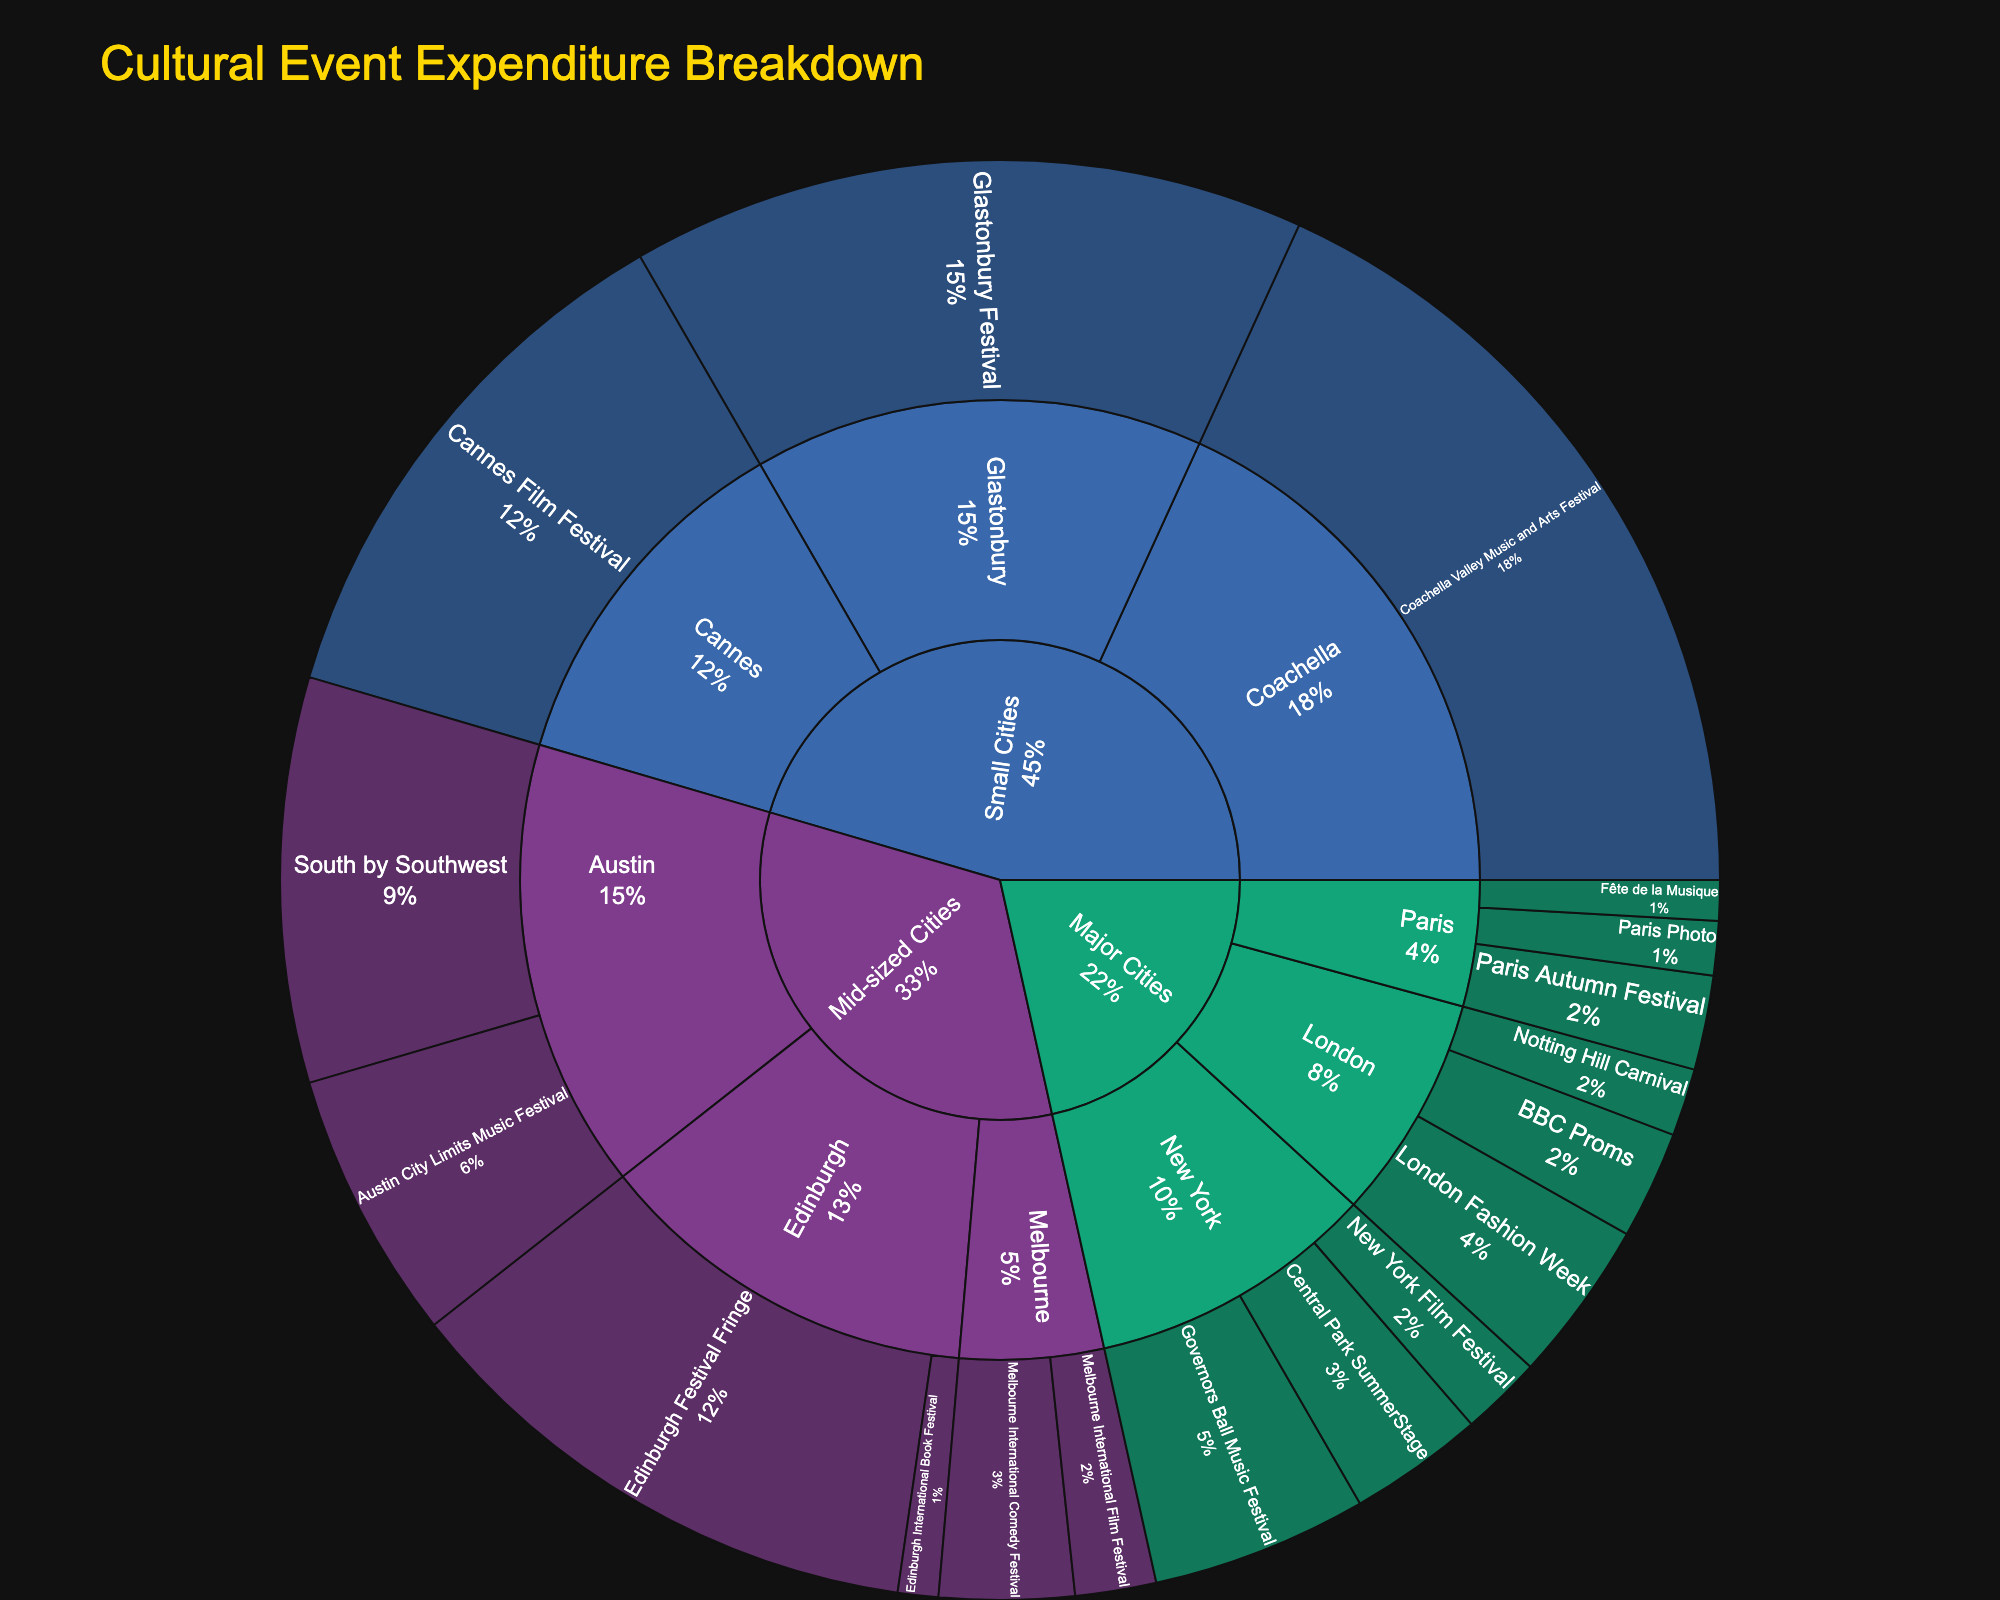what is the title of the plot? The title is usually at the top of the plot. For this sunburst chart, it's labeled as 'Cultural Event Expenditure Breakdown'.
Answer: Cultural Event Expenditure Breakdown Which event in Small Cities has the highest expenditure? In the plot, the largest segment under Small Cities with the most expenditure is the 'Coachella Valley Music and Arts Festival', indicated by the largest size and expenditure label.
Answer: Coachella Valley Music and Arts Festival What is the total expenditure for events in London? Under the 'London' segment, sum up the expenditures for 'Notting Hill Carnival' (2,500,000), 'BBC Proms' (4,000,000), and 'London Fashion Week' (6,000,000). The total is 2,500,000 + 4,000,000 + 6,000,000 = 12,500,000.
Answer: 12,500,000 Which subcategory has the highest overall expenditure of all cities? By comparing the total expenditures of all subcategories, 'Coachella', 'Edinburgh', and 'Austin' all fall under Mid-sized and Small Cities with larger segments. After assessing each, the 'Coachella' in Small Cities has the highest total of 30,000,000.
Answer: Coachella What is the proportion of the expenditure for 'Glastonbury Festival' relative to total cultural event expenditures in Small Cities? The total expenditure for Small Cities is (25,000,000 + 20,000,000 + 30,000,000 = 75,000,000). The expenditure for 'Glastonbury Festival' is 25,000,000. The proportion is 25,000,000 / 75,000,000 = 1/3 or approximately 33.33%.
Answer: 33.33% Which city in Major Cities category has the lowest expenditure? Reviewing each segment under Major Cities, the expenditures are: New York - (5,000,000 + 8,000,000 + 3,000,000) = 16,000,000; London - (2,500,000 + 4,000,000 + 6,000,000) = 12,500,000; Paris - (1,500,000 + 3,500,000 + 2,000,000) = 7,000,000. Hence, Paris has the lowest expenditure.
Answer: Paris What's the average expenditure for events in Austin? Sum the expenditures for Austin events: 'South by Southwest' (15,000,000) and 'Austin City Limits Music Festival' (10,000,000) giving a total of 25,000,000. Divide by the number of events (2), thus 25,000,000 / 2 = 12,500,000.
Answer: 12,500,000 Compare the total expenditures of New York and London. Which is greater and by how much? New York total is (5,000,000 + 8,000,000 + 3,000,000) = 16,000,000; London total is (2,500,000 + 4,000,000 + 6,000,000) = 12,500,000. New York is greater by (16,000,000 - 12,500,000) = 3,500,000.
Answer: New York; 3,500,000 Which type of event has the maximum expenditure in Mid-sized Cities? Under Mid-sized Cities, the event with the largest segment (and therefore the highest expenditure) is 'Edinburgh Festival Fringe' with an expenditure of 20,000,000.
Answer: Edinburgh Festival Fringe What is the combined expenditure of the top two highest expenditure events overall? The highest is 'Coachella Valley Music and Arts Festival' (30,000,000) and the next highest is 'Glastonbury Festival' (25,000,000). Their combined expenditure is 30,000,000 + 25,000,000 = 55,000,000.
Answer: 55,000,000 